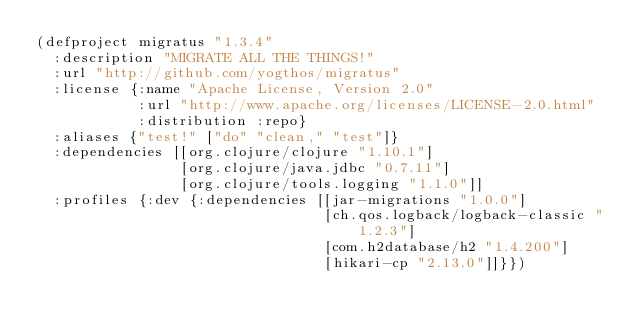Convert code to text. <code><loc_0><loc_0><loc_500><loc_500><_Clojure_>(defproject migratus "1.3.4"
  :description "MIGRATE ALL THE THINGS!"
  :url "http://github.com/yogthos/migratus"
  :license {:name "Apache License, Version 2.0"
            :url "http://www.apache.org/licenses/LICENSE-2.0.html"
            :distribution :repo}
  :aliases {"test!" ["do" "clean," "test"]}
  :dependencies [[org.clojure/clojure "1.10.1"]
                 [org.clojure/java.jdbc "0.7.11"]
                 [org.clojure/tools.logging "1.1.0"]]
  :profiles {:dev {:dependencies [[jar-migrations "1.0.0"]
                                  [ch.qos.logback/logback-classic "1.2.3"]
                                  [com.h2database/h2 "1.4.200"]
                                  [hikari-cp "2.13.0"]]}})
</code> 